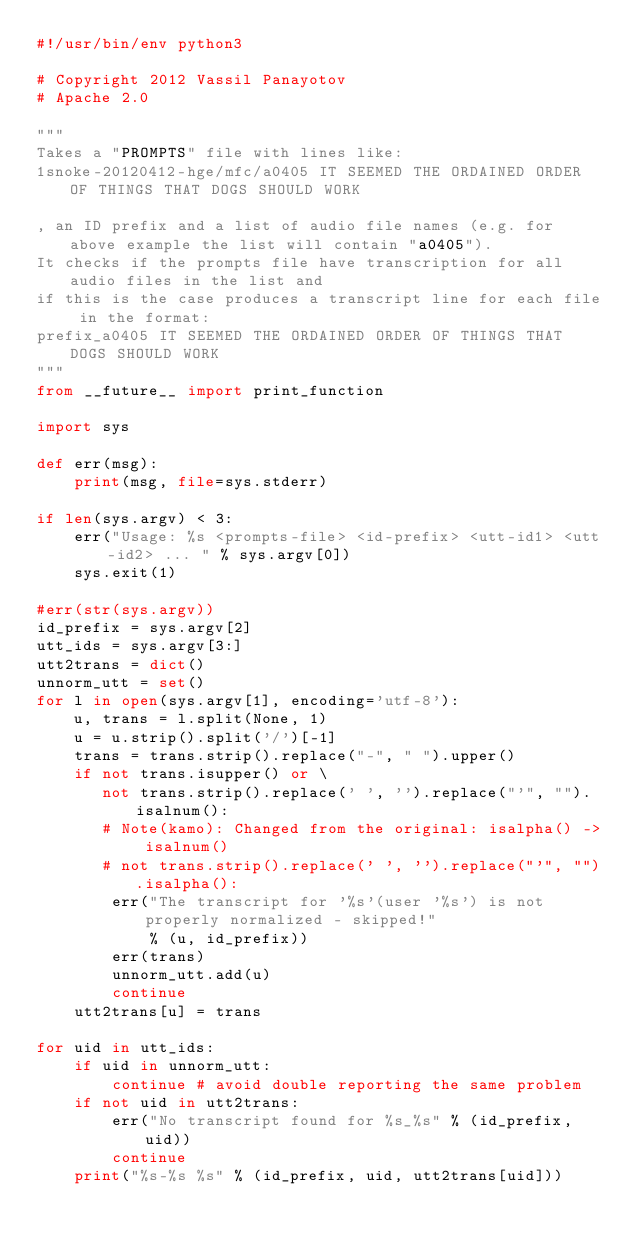Convert code to text. <code><loc_0><loc_0><loc_500><loc_500><_Python_>#!/usr/bin/env python3

# Copyright 2012 Vassil Panayotov
# Apache 2.0

"""
Takes a "PROMPTS" file with lines like:
1snoke-20120412-hge/mfc/a0405 IT SEEMED THE ORDAINED ORDER OF THINGS THAT DOGS SHOULD WORK

, an ID prefix and a list of audio file names (e.g. for above example the list will contain "a0405").
It checks if the prompts file have transcription for all audio files in the list and
if this is the case produces a transcript line for each file in the format:
prefix_a0405 IT SEEMED THE ORDAINED ORDER OF THINGS THAT DOGS SHOULD WORK
"""
from __future__ import print_function

import sys

def err(msg):
    print(msg, file=sys.stderr)

if len(sys.argv) < 3:
    err("Usage: %s <prompts-file> <id-prefix> <utt-id1> <utt-id2> ... " % sys.argv[0])
    sys.exit(1)

#err(str(sys.argv))
id_prefix = sys.argv[2]
utt_ids = sys.argv[3:]
utt2trans = dict()
unnorm_utt = set() 
for l in open(sys.argv[1], encoding='utf-8'):
    u, trans = l.split(None, 1)
    u = u.strip().split('/')[-1]
    trans = trans.strip().replace("-", " ").upper()
    if not trans.isupper() or \
       not trans.strip().replace(' ', '').replace("'", "").isalnum():
       # Note(kamo): Changed from the original: isalpha() -> isalnum()
       # not trans.strip().replace(' ', '').replace("'", "").isalpha():
        err("The transcript for '%s'(user '%s') is not properly normalized - skipped!"
            % (u, id_prefix))
        err(trans)
        unnorm_utt.add(u)
        continue
    utt2trans[u] = trans

for uid in utt_ids:
    if uid in unnorm_utt:
        continue # avoid double reporting the same problem
    if not uid in utt2trans:
        err("No transcript found for %s_%s" % (id_prefix, uid))
        continue
    print("%s-%s %s" % (id_prefix, uid, utt2trans[uid]))

</code> 